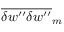Convert formula to latex. <formula><loc_0><loc_0><loc_500><loc_500>\overline { { { \delta w ^ { \prime \prime } \delta w ^ { \prime \prime } } } } _ { m }</formula> 